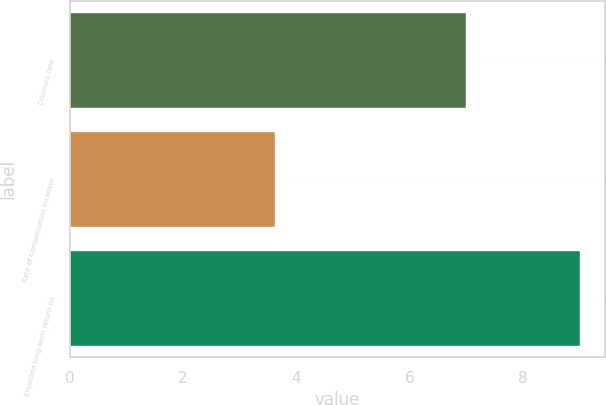Convert chart to OTSL. <chart><loc_0><loc_0><loc_500><loc_500><bar_chart><fcel>Discount rate<fcel>Rate of compensation increase<fcel>Expected long-term return on<nl><fcel>7<fcel>3.62<fcel>9<nl></chart> 